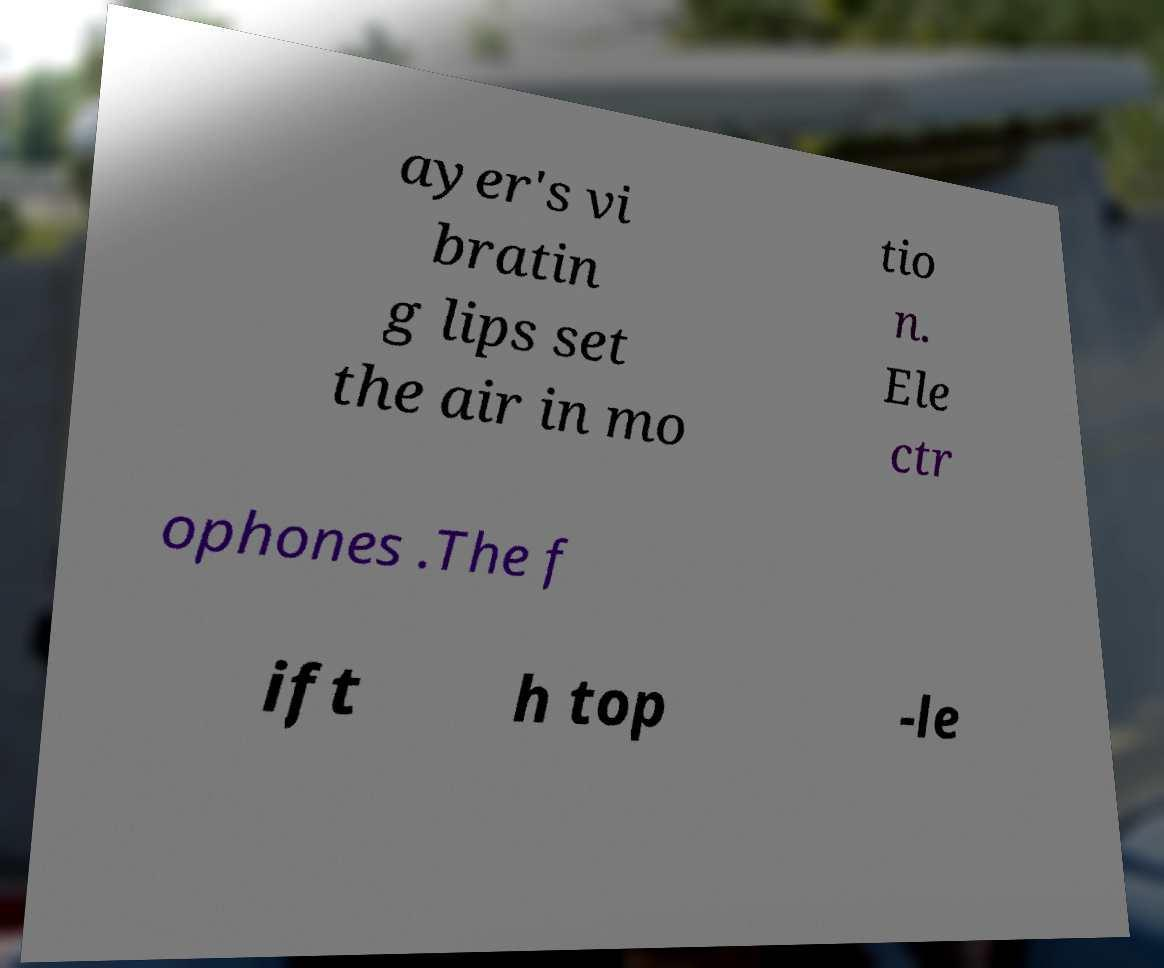Can you accurately transcribe the text from the provided image for me? ayer's vi bratin g lips set the air in mo tio n. Ele ctr ophones .The f ift h top -le 